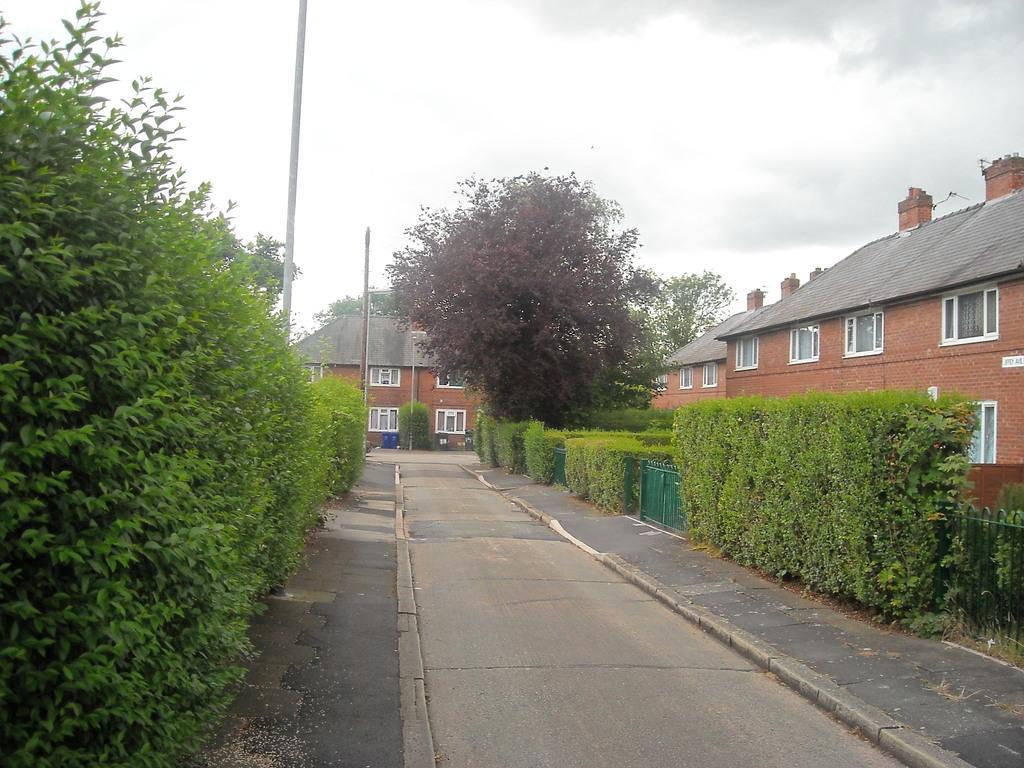Could you give a brief overview of what you see in this image? In this image on both sides of the path there are trees, plants. These are buildings. This is a pole. The sky is cloudy. 